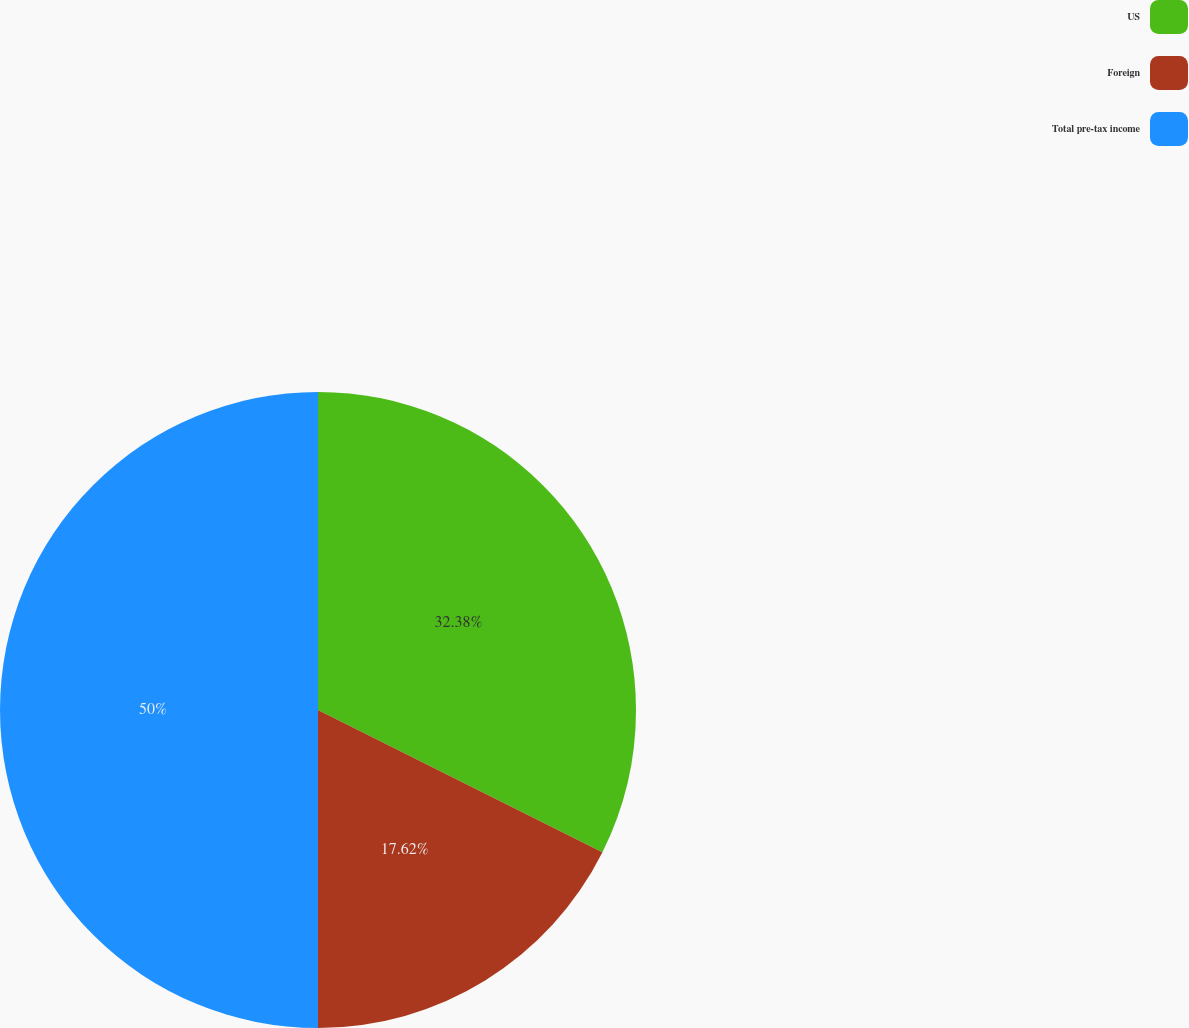Convert chart. <chart><loc_0><loc_0><loc_500><loc_500><pie_chart><fcel>US<fcel>Foreign<fcel>Total pre-tax income<nl><fcel>32.38%<fcel>17.62%<fcel>50.0%<nl></chart> 